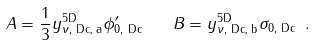Convert formula to latex. <formula><loc_0><loc_0><loc_500><loc_500>A = \frac { 1 } { 3 } y _ { \nu , \text { Dc, a} } ^ { \text {5D} } \phi _ { 0 , \text { Dc} } ^ { \prime } \quad B = y _ { \nu , \text { Dc, b} } ^ { \text {5D} } \sigma _ { 0 , \text { Dc} } \ .</formula> 